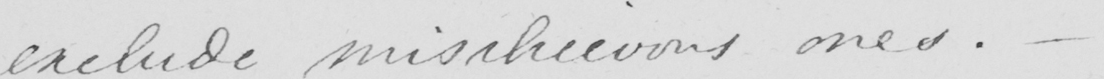What is written in this line of handwriting? exclude mischievous ones .  _ 